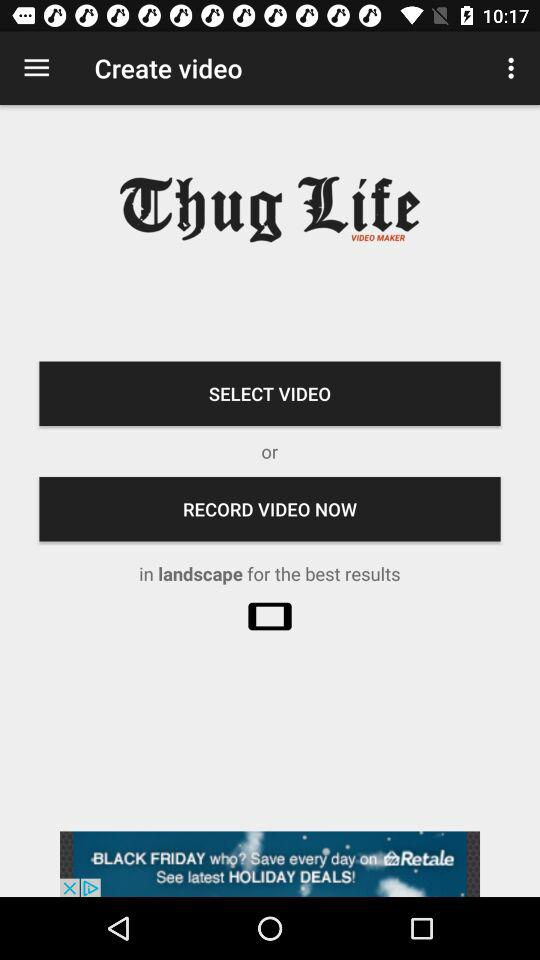What is the application name? The application name is "Thug Life VIDEO MAKER". 